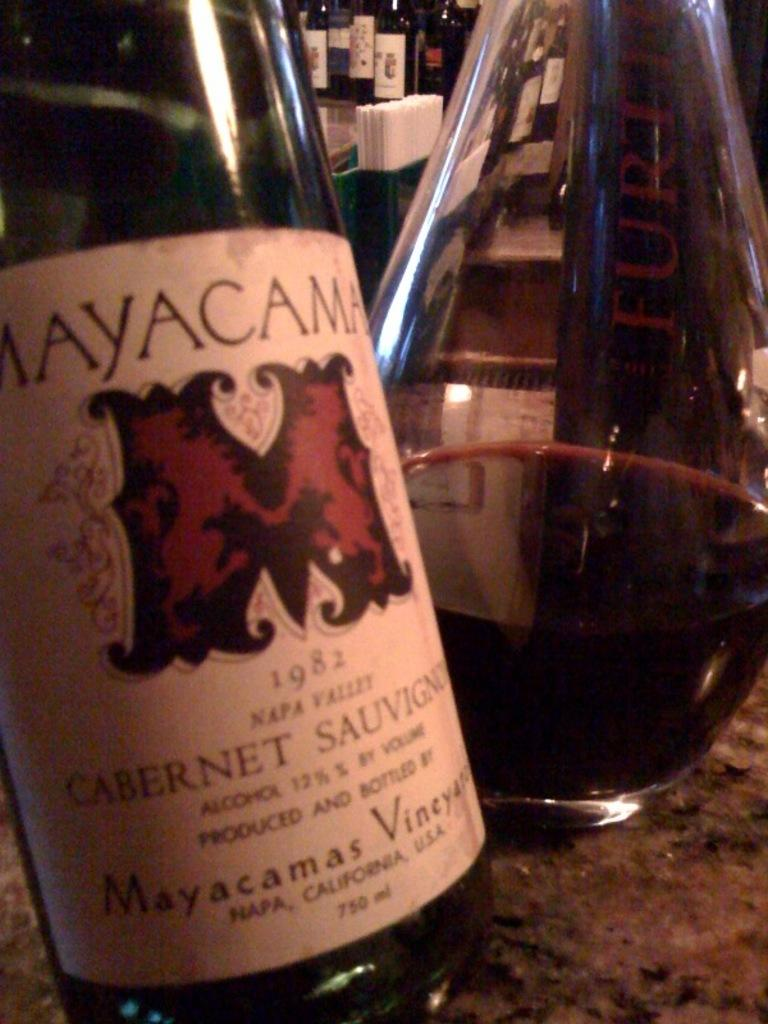<image>
Relay a brief, clear account of the picture shown. a wine bottle that says 'mayacama' at the top of the label 